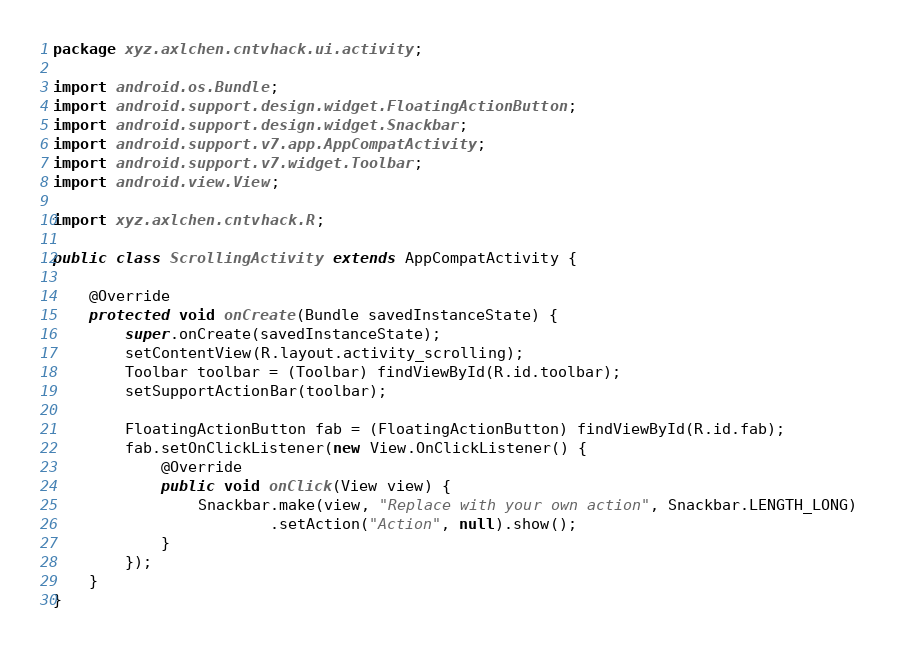<code> <loc_0><loc_0><loc_500><loc_500><_Java_>package xyz.axlchen.cntvhack.ui.activity;

import android.os.Bundle;
import android.support.design.widget.FloatingActionButton;
import android.support.design.widget.Snackbar;
import android.support.v7.app.AppCompatActivity;
import android.support.v7.widget.Toolbar;
import android.view.View;

import xyz.axlchen.cntvhack.R;

public class ScrollingActivity extends AppCompatActivity {

    @Override
    protected void onCreate(Bundle savedInstanceState) {
        super.onCreate(savedInstanceState);
        setContentView(R.layout.activity_scrolling);
        Toolbar toolbar = (Toolbar) findViewById(R.id.toolbar);
        setSupportActionBar(toolbar);

        FloatingActionButton fab = (FloatingActionButton) findViewById(R.id.fab);
        fab.setOnClickListener(new View.OnClickListener() {
            @Override
            public void onClick(View view) {
                Snackbar.make(view, "Replace with your own action", Snackbar.LENGTH_LONG)
                        .setAction("Action", null).show();
            }
        });
    }
}
</code> 